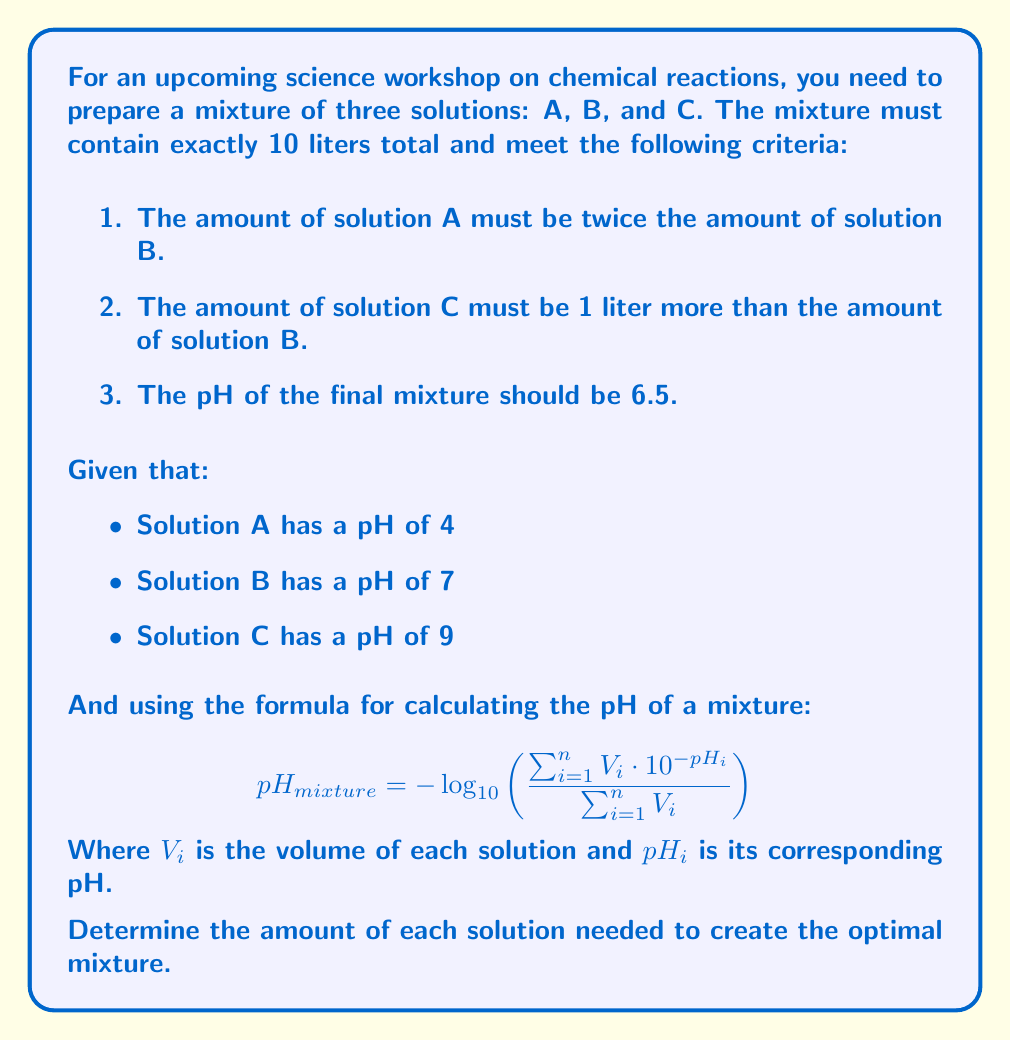Give your solution to this math problem. Let's approach this step-by-step:

1) Let's define our variables:
   Let $x$ be the amount of solution B in liters.
   Then, $2x$ is the amount of solution A.
   And $x + 1$ is the amount of solution C.

2) We can set up our first equation based on the total volume:
   $2x + x + (x + 1) = 10$
   $4x + 1 = 10$
   $4x = 9$
   $x = 2.25$

3) Now we know:
   Solution B: $x = 2.25$ liters
   Solution A: $2x = 4.5$ liters
   Solution C: $x + 1 = 3.25$ liters

4) Let's verify if this mixture gives us the desired pH of 6.5 using the given formula:

   $$ 6.5 = -\log_{10}\left(\frac{4.5 \cdot 10^{-4} + 2.25 \cdot 10^{-7} + 3.25 \cdot 10^{-9}}{4.5 + 2.25 + 3.25}\right) $$

5) Let's calculate the right side:

   $$ -\log_{10}\left(\frac{4.5 \cdot 10^{-4} + 2.25 \cdot 10^{-7} + 3.25 \cdot 10^{-9}}{10}\right) $$
   $$ = -\log_{10}(4.5025 \cdot 10^{-5}) $$
   $$ \approx 6.5 $$

6) The calculation confirms that our mixture indeed results in a pH of 6.5, validating our solution.
Answer: The optimal mixture requires:
Solution A: 4.5 liters
Solution B: 2.25 liters
Solution C: 3.25 liters 